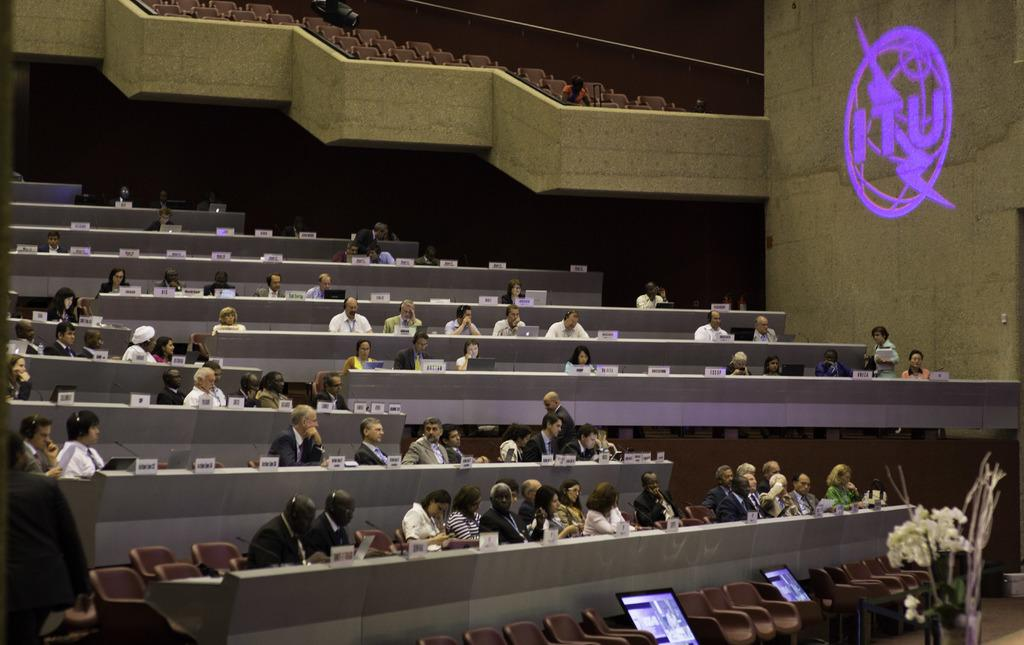What are the people in the image doing? The people in the image are sitting on chairs. Can you describe the lighting in the image? There is a light on a wall on the right side. How does the distribution of breath affect the train in the image? There is no train present in the image, and therefore no such distribution of breath can be observed. 